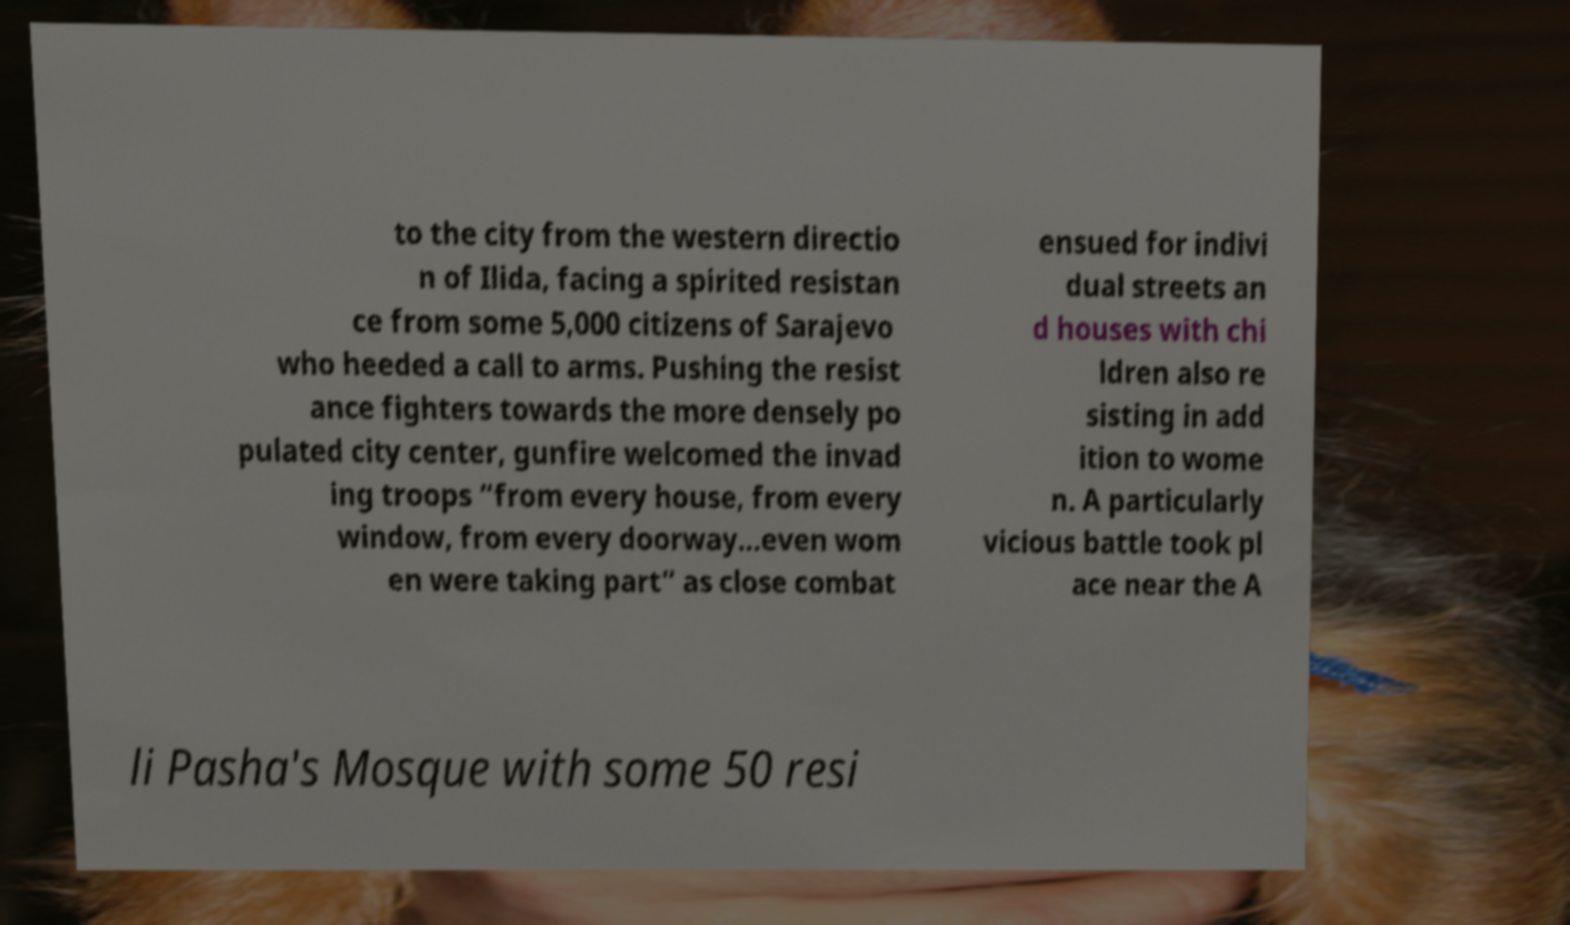Can you accurately transcribe the text from the provided image for me? to the city from the western directio n of Ilida, facing a spirited resistan ce from some 5,000 citizens of Sarajevo who heeded a call to arms. Pushing the resist ance fighters towards the more densely po pulated city center, gunfire welcomed the invad ing troops “from every house, from every window, from every doorway…even wom en were taking part” as close combat ensued for indivi dual streets an d houses with chi ldren also re sisting in add ition to wome n. A particularly vicious battle took pl ace near the A li Pasha's Mosque with some 50 resi 